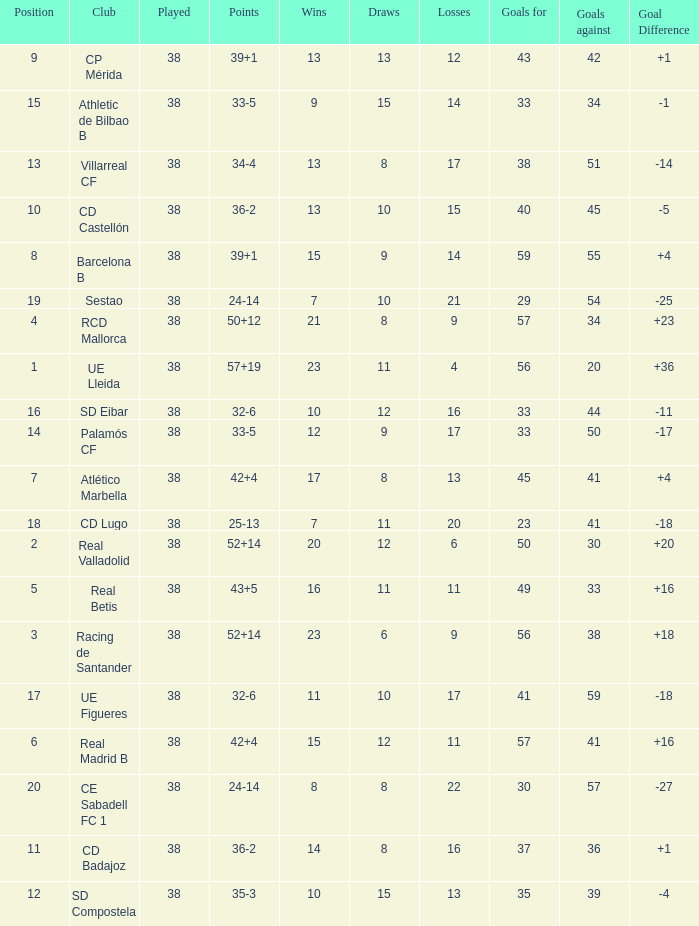What is the average goal difference with 51 goals scored against and less than 17 losses? None. 